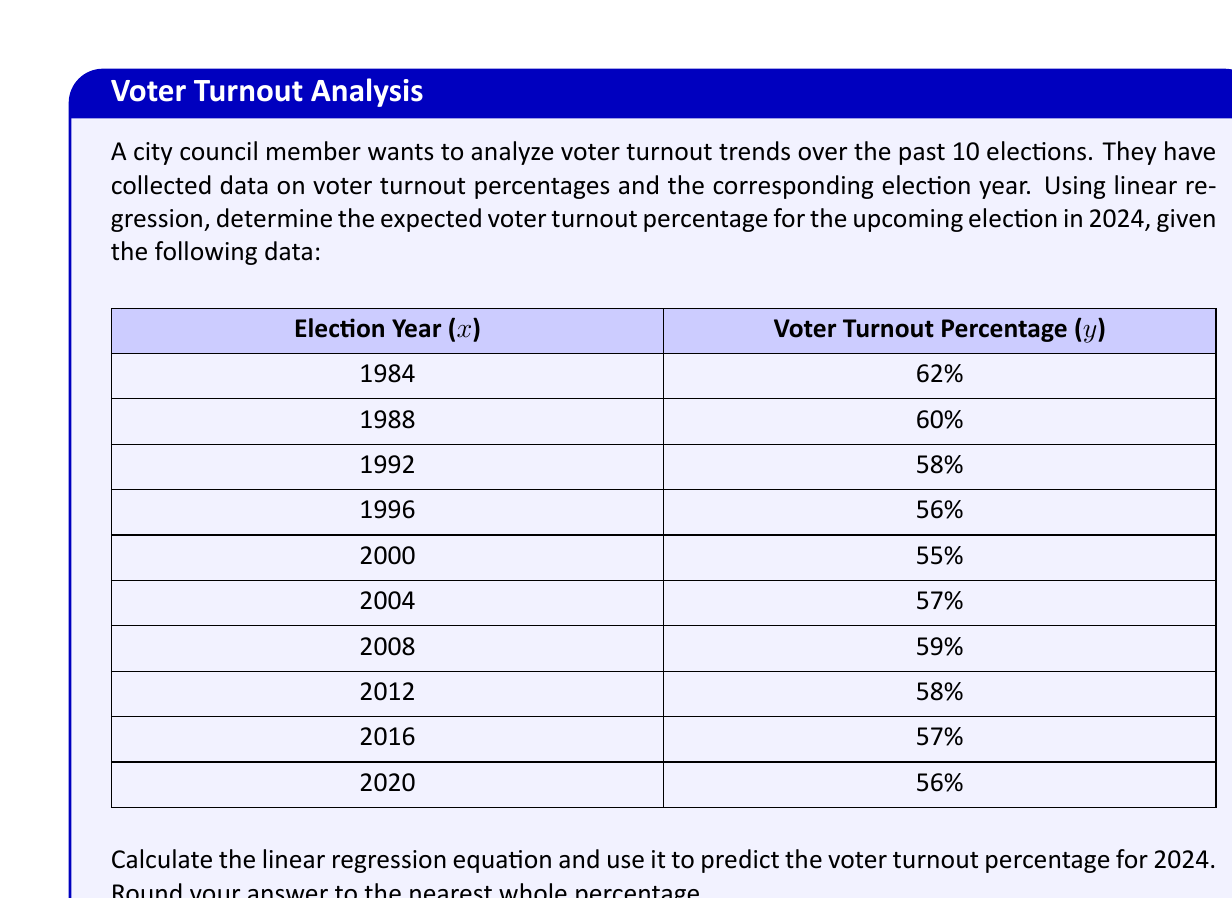Can you answer this question? To solve this problem, we'll use linear regression to find the line of best fit for the given data and then use that equation to predict the voter turnout for 2024. Let's follow these steps:

1. Calculate the means of $x$ (election year) and $y$ (voter turnout percentage):
   $\bar{x} = \frac{1984 + 1988 + ... + 2020}{10} = 2000$
   $\bar{y} = \frac{62 + 60 + ... + 56}{10} = 57.8$

2. Calculate the slope ($m$) of the regression line using the formula:
   $$m = \frac{\sum(x_i - \bar{x})(y_i - \bar{y})}{\sum(x_i - \bar{x})^2}$$

3. Calculate the y-intercept ($b$) using the formula:
   $$b = \bar{y} - m\bar{x}$$

4. Form the linear regression equation:
   $$y = mx + b$$

5. Use the equation to predict the voter turnout for 2024.

Calculations:

For the slope:
$\sum(x_i - \bar{x})(y_i - \bar{y}) = -1140$
$\sum(x_i - \bar{x})^2 = 1140$

$m = \frac{-1140}{1140} = -1$

For the y-intercept:
$b = 57.8 - (-1 \times 2000) = 2057.8$

The linear regression equation is:
$$y = -x + 2057.8$$

To predict the voter turnout for 2024:
$y = -2024 + 2057.8 = 33.8$

Rounding to the nearest whole percentage: 34%
Answer: 34% 